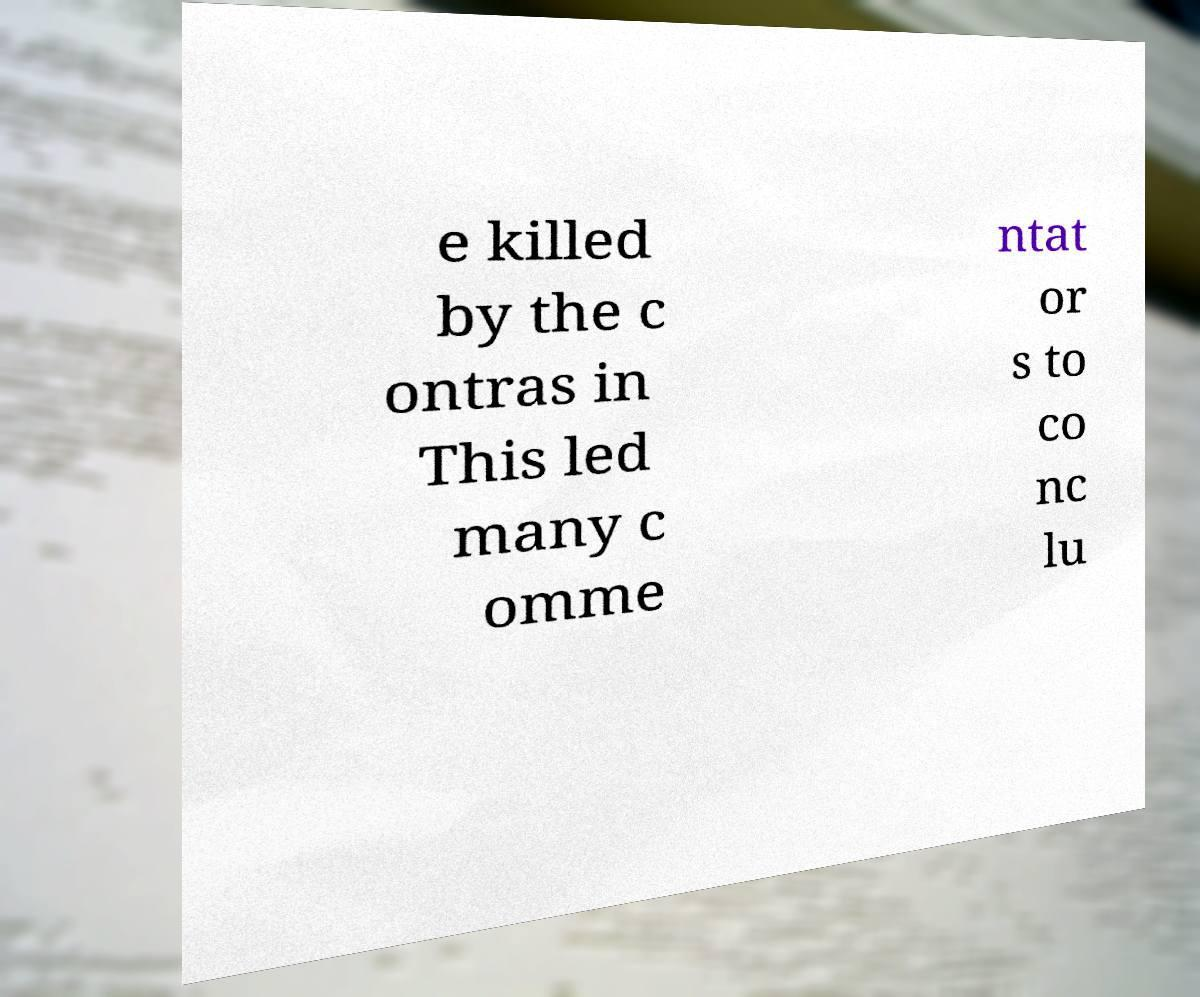For documentation purposes, I need the text within this image transcribed. Could you provide that? e killed by the c ontras in This led many c omme ntat or s to co nc lu 